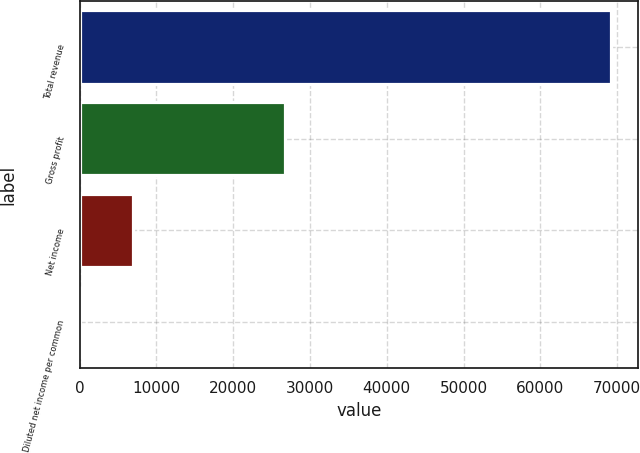<chart> <loc_0><loc_0><loc_500><loc_500><bar_chart><fcel>Total revenue<fcel>Gross profit<fcel>Net income<fcel>Diluted net income per common<nl><fcel>69237<fcel>26773<fcel>6923.82<fcel>0.13<nl></chart> 